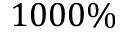<formula> <loc_0><loc_0><loc_500><loc_500>1 0 0 0 \%</formula> 